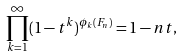<formula> <loc_0><loc_0><loc_500><loc_500>\prod _ { k = 1 } ^ { \infty } ( 1 - t ^ { k } ) ^ { \phi _ { k } ( F _ { n } ) } = 1 - n t ,</formula> 